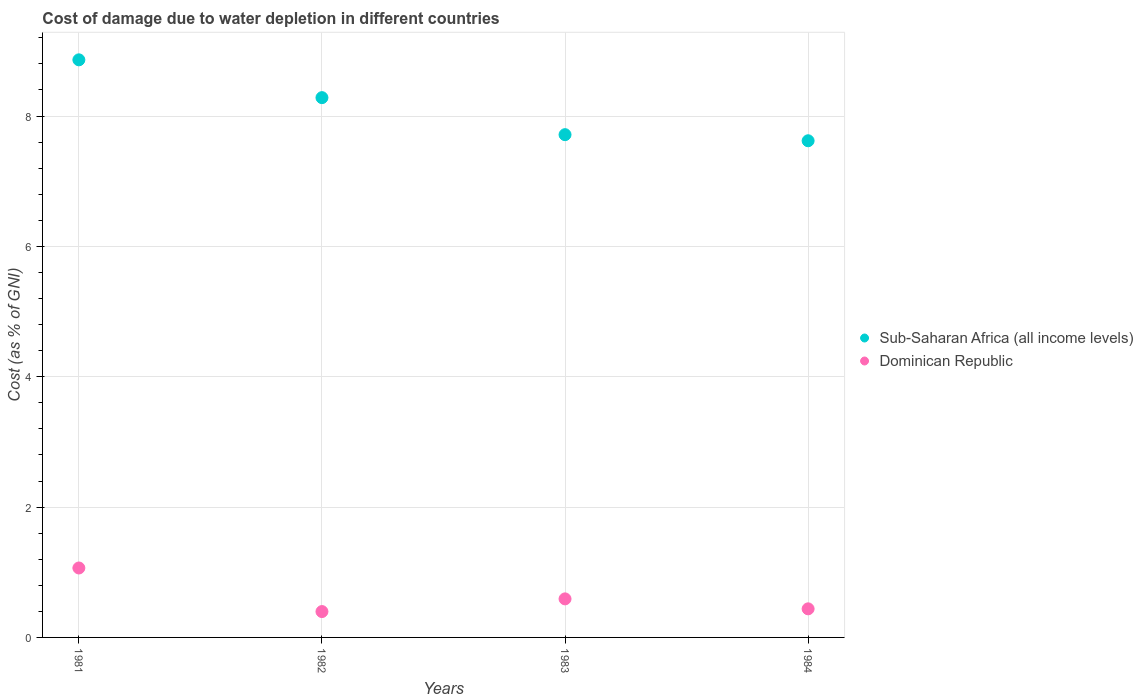How many different coloured dotlines are there?
Your response must be concise. 2. Is the number of dotlines equal to the number of legend labels?
Give a very brief answer. Yes. What is the cost of damage caused due to water depletion in Sub-Saharan Africa (all income levels) in 1982?
Offer a very short reply. 8.28. Across all years, what is the maximum cost of damage caused due to water depletion in Dominican Republic?
Offer a terse response. 1.07. Across all years, what is the minimum cost of damage caused due to water depletion in Dominican Republic?
Your answer should be compact. 0.4. What is the total cost of damage caused due to water depletion in Dominican Republic in the graph?
Ensure brevity in your answer.  2.49. What is the difference between the cost of damage caused due to water depletion in Sub-Saharan Africa (all income levels) in 1983 and that in 1984?
Your response must be concise. 0.09. What is the difference between the cost of damage caused due to water depletion in Sub-Saharan Africa (all income levels) in 1984 and the cost of damage caused due to water depletion in Dominican Republic in 1982?
Provide a short and direct response. 7.22. What is the average cost of damage caused due to water depletion in Sub-Saharan Africa (all income levels) per year?
Give a very brief answer. 8.12. In the year 1981, what is the difference between the cost of damage caused due to water depletion in Dominican Republic and cost of damage caused due to water depletion in Sub-Saharan Africa (all income levels)?
Give a very brief answer. -7.8. In how many years, is the cost of damage caused due to water depletion in Dominican Republic greater than 8 %?
Make the answer very short. 0. What is the ratio of the cost of damage caused due to water depletion in Sub-Saharan Africa (all income levels) in 1981 to that in 1984?
Your answer should be very brief. 1.16. Is the cost of damage caused due to water depletion in Sub-Saharan Africa (all income levels) in 1982 less than that in 1983?
Make the answer very short. No. Is the difference between the cost of damage caused due to water depletion in Dominican Republic in 1982 and 1983 greater than the difference between the cost of damage caused due to water depletion in Sub-Saharan Africa (all income levels) in 1982 and 1983?
Your response must be concise. No. What is the difference between the highest and the second highest cost of damage caused due to water depletion in Dominican Republic?
Offer a terse response. 0.47. What is the difference between the highest and the lowest cost of damage caused due to water depletion in Dominican Republic?
Offer a very short reply. 0.67. Does the cost of damage caused due to water depletion in Dominican Republic monotonically increase over the years?
Give a very brief answer. No. What is the difference between two consecutive major ticks on the Y-axis?
Offer a very short reply. 2. Are the values on the major ticks of Y-axis written in scientific E-notation?
Make the answer very short. No. How many legend labels are there?
Provide a short and direct response. 2. What is the title of the graph?
Keep it short and to the point. Cost of damage due to water depletion in different countries. What is the label or title of the Y-axis?
Provide a short and direct response. Cost (as % of GNI). What is the Cost (as % of GNI) of Sub-Saharan Africa (all income levels) in 1981?
Provide a short and direct response. 8.86. What is the Cost (as % of GNI) in Dominican Republic in 1981?
Make the answer very short. 1.07. What is the Cost (as % of GNI) of Sub-Saharan Africa (all income levels) in 1982?
Give a very brief answer. 8.28. What is the Cost (as % of GNI) in Dominican Republic in 1982?
Offer a terse response. 0.4. What is the Cost (as % of GNI) of Sub-Saharan Africa (all income levels) in 1983?
Offer a very short reply. 7.71. What is the Cost (as % of GNI) in Dominican Republic in 1983?
Provide a succinct answer. 0.59. What is the Cost (as % of GNI) in Sub-Saharan Africa (all income levels) in 1984?
Provide a succinct answer. 7.62. What is the Cost (as % of GNI) in Dominican Republic in 1984?
Make the answer very short. 0.44. Across all years, what is the maximum Cost (as % of GNI) in Sub-Saharan Africa (all income levels)?
Your response must be concise. 8.86. Across all years, what is the maximum Cost (as % of GNI) of Dominican Republic?
Provide a short and direct response. 1.07. Across all years, what is the minimum Cost (as % of GNI) of Sub-Saharan Africa (all income levels)?
Your answer should be very brief. 7.62. Across all years, what is the minimum Cost (as % of GNI) of Dominican Republic?
Keep it short and to the point. 0.4. What is the total Cost (as % of GNI) of Sub-Saharan Africa (all income levels) in the graph?
Provide a short and direct response. 32.48. What is the total Cost (as % of GNI) in Dominican Republic in the graph?
Ensure brevity in your answer.  2.49. What is the difference between the Cost (as % of GNI) in Sub-Saharan Africa (all income levels) in 1981 and that in 1982?
Offer a terse response. 0.58. What is the difference between the Cost (as % of GNI) in Dominican Republic in 1981 and that in 1982?
Your answer should be very brief. 0.67. What is the difference between the Cost (as % of GNI) of Sub-Saharan Africa (all income levels) in 1981 and that in 1983?
Make the answer very short. 1.15. What is the difference between the Cost (as % of GNI) of Dominican Republic in 1981 and that in 1983?
Your answer should be very brief. 0.47. What is the difference between the Cost (as % of GNI) of Sub-Saharan Africa (all income levels) in 1981 and that in 1984?
Make the answer very short. 1.24. What is the difference between the Cost (as % of GNI) of Dominican Republic in 1981 and that in 1984?
Provide a short and direct response. 0.63. What is the difference between the Cost (as % of GNI) of Sub-Saharan Africa (all income levels) in 1982 and that in 1983?
Ensure brevity in your answer.  0.57. What is the difference between the Cost (as % of GNI) of Dominican Republic in 1982 and that in 1983?
Keep it short and to the point. -0.19. What is the difference between the Cost (as % of GNI) of Sub-Saharan Africa (all income levels) in 1982 and that in 1984?
Offer a terse response. 0.66. What is the difference between the Cost (as % of GNI) in Dominican Republic in 1982 and that in 1984?
Provide a succinct answer. -0.04. What is the difference between the Cost (as % of GNI) in Sub-Saharan Africa (all income levels) in 1983 and that in 1984?
Make the answer very short. 0.09. What is the difference between the Cost (as % of GNI) of Dominican Republic in 1983 and that in 1984?
Your answer should be very brief. 0.15. What is the difference between the Cost (as % of GNI) in Sub-Saharan Africa (all income levels) in 1981 and the Cost (as % of GNI) in Dominican Republic in 1982?
Keep it short and to the point. 8.47. What is the difference between the Cost (as % of GNI) in Sub-Saharan Africa (all income levels) in 1981 and the Cost (as % of GNI) in Dominican Republic in 1983?
Your answer should be very brief. 8.27. What is the difference between the Cost (as % of GNI) of Sub-Saharan Africa (all income levels) in 1981 and the Cost (as % of GNI) of Dominican Republic in 1984?
Make the answer very short. 8.42. What is the difference between the Cost (as % of GNI) in Sub-Saharan Africa (all income levels) in 1982 and the Cost (as % of GNI) in Dominican Republic in 1983?
Offer a very short reply. 7.69. What is the difference between the Cost (as % of GNI) of Sub-Saharan Africa (all income levels) in 1982 and the Cost (as % of GNI) of Dominican Republic in 1984?
Your answer should be compact. 7.84. What is the difference between the Cost (as % of GNI) of Sub-Saharan Africa (all income levels) in 1983 and the Cost (as % of GNI) of Dominican Republic in 1984?
Keep it short and to the point. 7.28. What is the average Cost (as % of GNI) in Sub-Saharan Africa (all income levels) per year?
Provide a succinct answer. 8.12. What is the average Cost (as % of GNI) in Dominican Republic per year?
Offer a very short reply. 0.62. In the year 1981, what is the difference between the Cost (as % of GNI) of Sub-Saharan Africa (all income levels) and Cost (as % of GNI) of Dominican Republic?
Provide a short and direct response. 7.8. In the year 1982, what is the difference between the Cost (as % of GNI) of Sub-Saharan Africa (all income levels) and Cost (as % of GNI) of Dominican Republic?
Ensure brevity in your answer.  7.89. In the year 1983, what is the difference between the Cost (as % of GNI) of Sub-Saharan Africa (all income levels) and Cost (as % of GNI) of Dominican Republic?
Provide a succinct answer. 7.12. In the year 1984, what is the difference between the Cost (as % of GNI) in Sub-Saharan Africa (all income levels) and Cost (as % of GNI) in Dominican Republic?
Give a very brief answer. 7.18. What is the ratio of the Cost (as % of GNI) of Sub-Saharan Africa (all income levels) in 1981 to that in 1982?
Ensure brevity in your answer.  1.07. What is the ratio of the Cost (as % of GNI) of Dominican Republic in 1981 to that in 1982?
Offer a terse response. 2.68. What is the ratio of the Cost (as % of GNI) in Sub-Saharan Africa (all income levels) in 1981 to that in 1983?
Keep it short and to the point. 1.15. What is the ratio of the Cost (as % of GNI) of Dominican Republic in 1981 to that in 1983?
Provide a succinct answer. 1.8. What is the ratio of the Cost (as % of GNI) of Sub-Saharan Africa (all income levels) in 1981 to that in 1984?
Ensure brevity in your answer.  1.16. What is the ratio of the Cost (as % of GNI) in Dominican Republic in 1981 to that in 1984?
Your answer should be very brief. 2.43. What is the ratio of the Cost (as % of GNI) in Sub-Saharan Africa (all income levels) in 1982 to that in 1983?
Offer a terse response. 1.07. What is the ratio of the Cost (as % of GNI) of Dominican Republic in 1982 to that in 1983?
Offer a terse response. 0.67. What is the ratio of the Cost (as % of GNI) of Sub-Saharan Africa (all income levels) in 1982 to that in 1984?
Offer a terse response. 1.09. What is the ratio of the Cost (as % of GNI) of Dominican Republic in 1982 to that in 1984?
Your response must be concise. 0.9. What is the ratio of the Cost (as % of GNI) in Sub-Saharan Africa (all income levels) in 1983 to that in 1984?
Provide a short and direct response. 1.01. What is the ratio of the Cost (as % of GNI) in Dominican Republic in 1983 to that in 1984?
Give a very brief answer. 1.35. What is the difference between the highest and the second highest Cost (as % of GNI) of Sub-Saharan Africa (all income levels)?
Your response must be concise. 0.58. What is the difference between the highest and the second highest Cost (as % of GNI) in Dominican Republic?
Your response must be concise. 0.47. What is the difference between the highest and the lowest Cost (as % of GNI) of Sub-Saharan Africa (all income levels)?
Offer a very short reply. 1.24. What is the difference between the highest and the lowest Cost (as % of GNI) in Dominican Republic?
Keep it short and to the point. 0.67. 